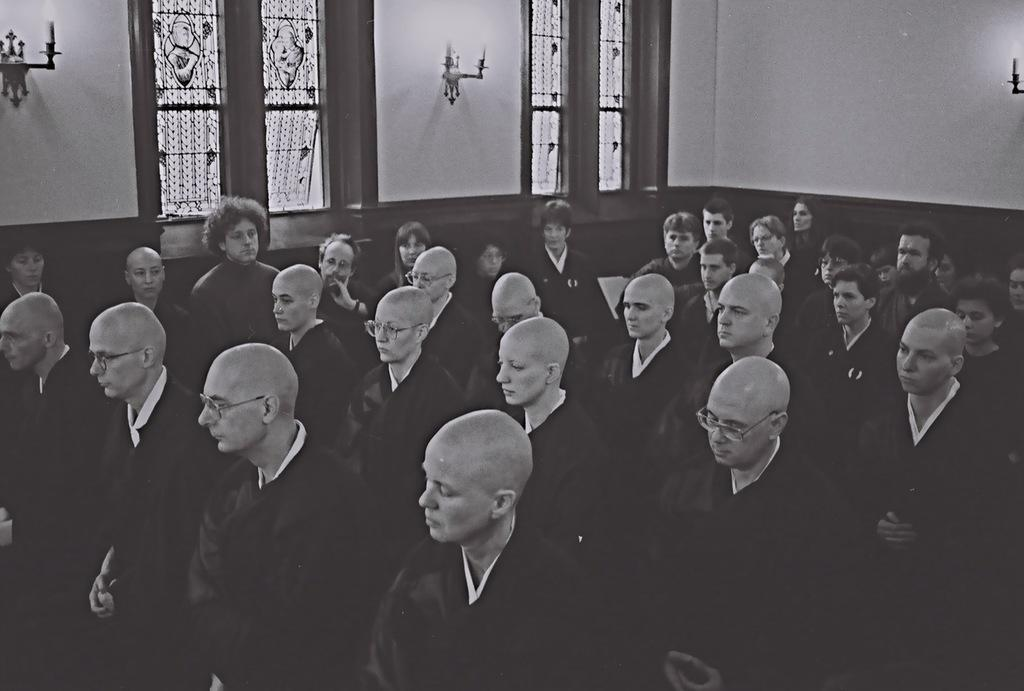What is the color scheme of the image? The image is black and white. How many people are visible in the image? There are many people standing in the image. What can be seen in the background of the image? There is a wall and windows in the background of the image. What type of calculator is being used by the person in the image? There is no calculator present in the image. Can you describe the bath that is visible in the image? There is no bath present in the image. 